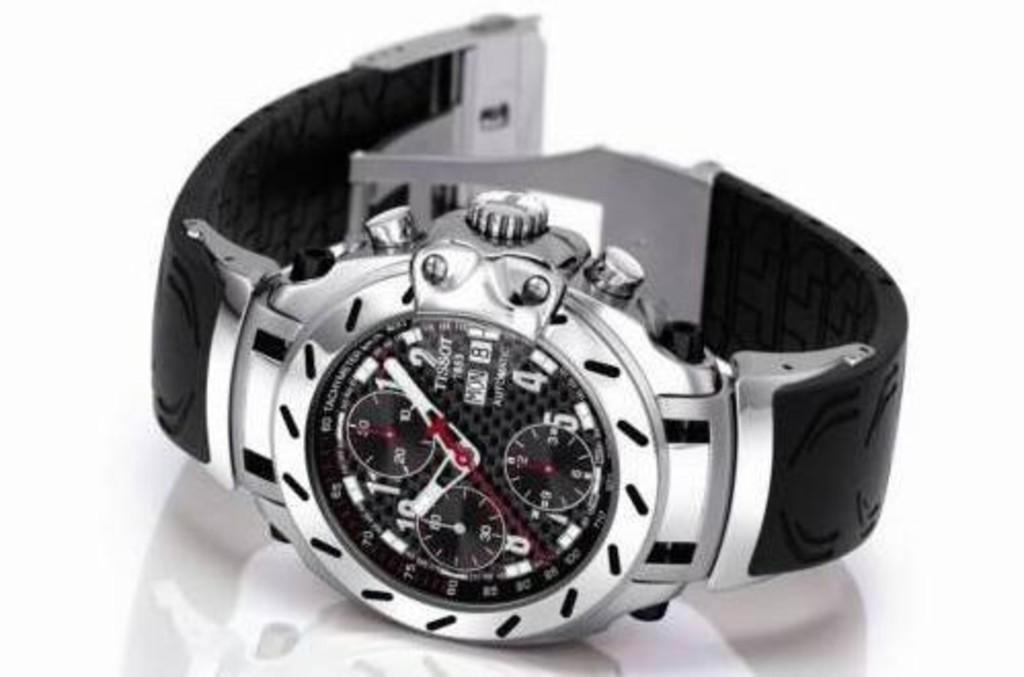Provide a one-sentence caption for the provided image. The black and silver watch is made by Tissot. 